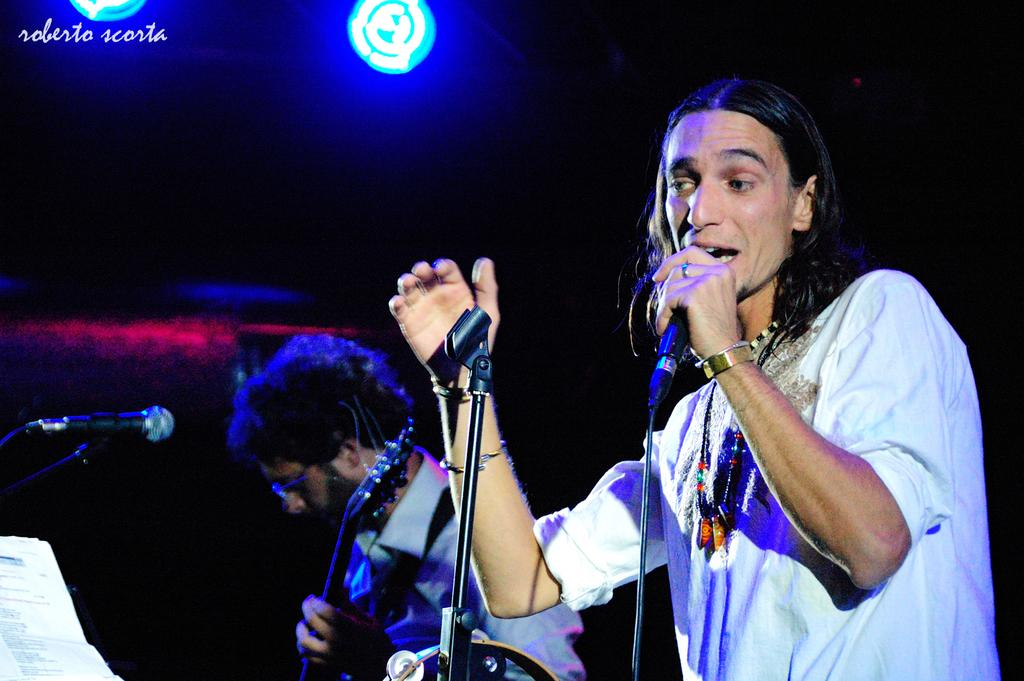What is the man in the image holding? The man is holding a microphone in the image. What is the man doing with the microphone? The man is singing while holding the microphone. Can you describe the other person in the image? There is another man in the image, and he is holding a guitar. How is the second man positioned in relation to the microphone? The second man is standing in front of a microphone. What type of game is the governor playing in the image? There is no governor present in the image, nor is there any indication of a game being played. 